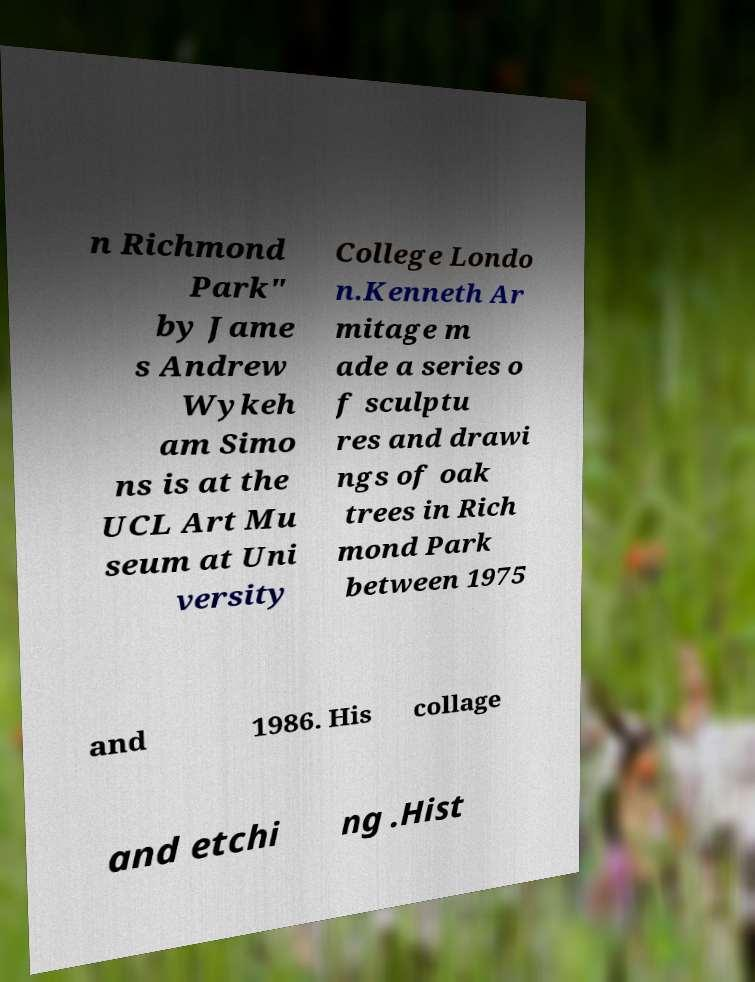Please read and relay the text visible in this image. What does it say? n Richmond Park" by Jame s Andrew Wykeh am Simo ns is at the UCL Art Mu seum at Uni versity College Londo n.Kenneth Ar mitage m ade a series o f sculptu res and drawi ngs of oak trees in Rich mond Park between 1975 and 1986. His collage and etchi ng .Hist 